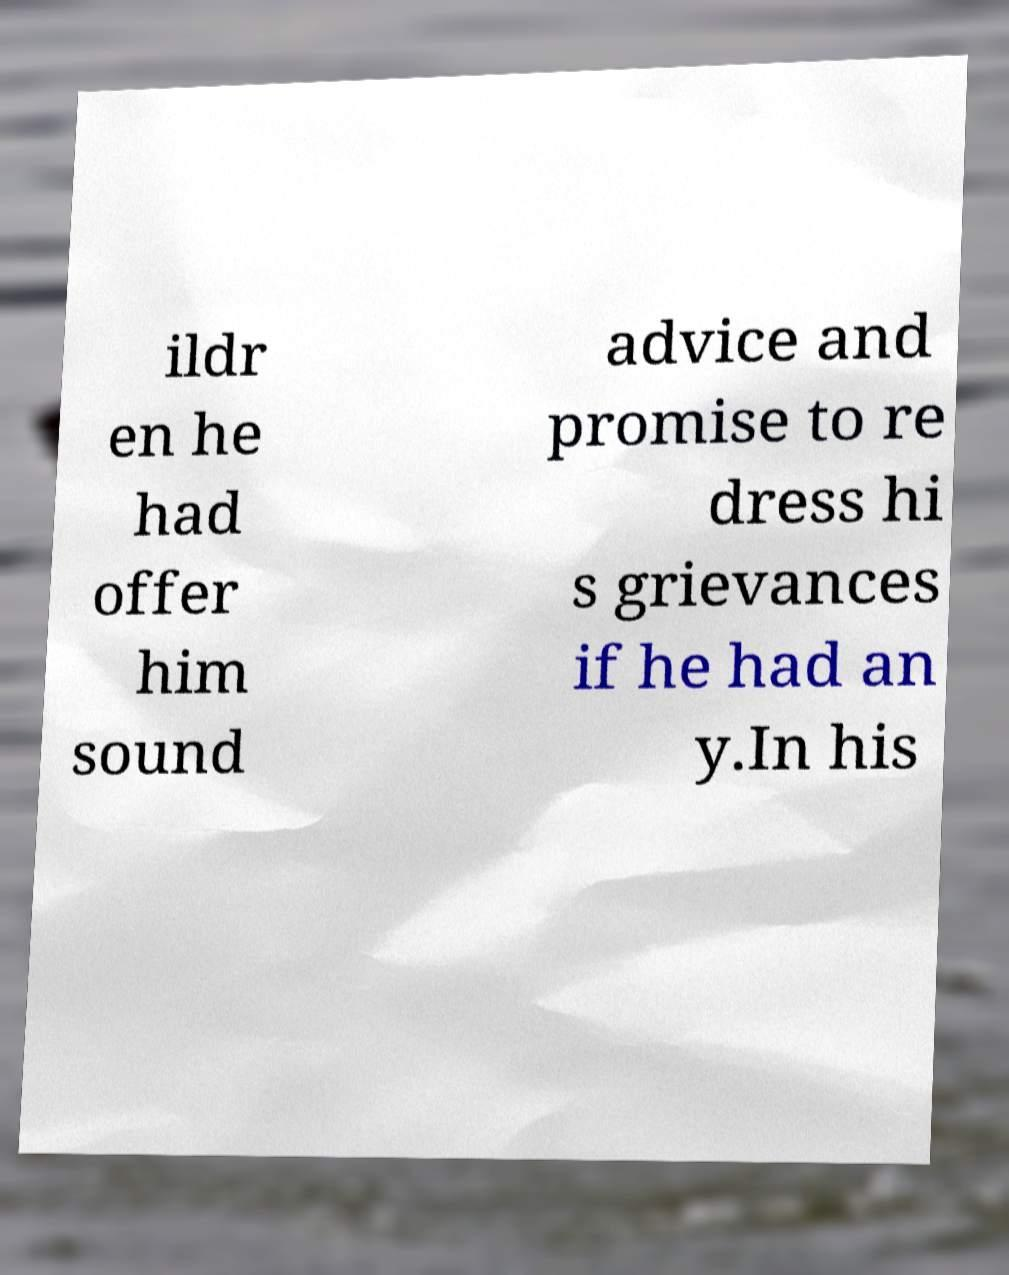There's text embedded in this image that I need extracted. Can you transcribe it verbatim? ildr en he had offer him sound advice and promise to re dress hi s grievances if he had an y.In his 